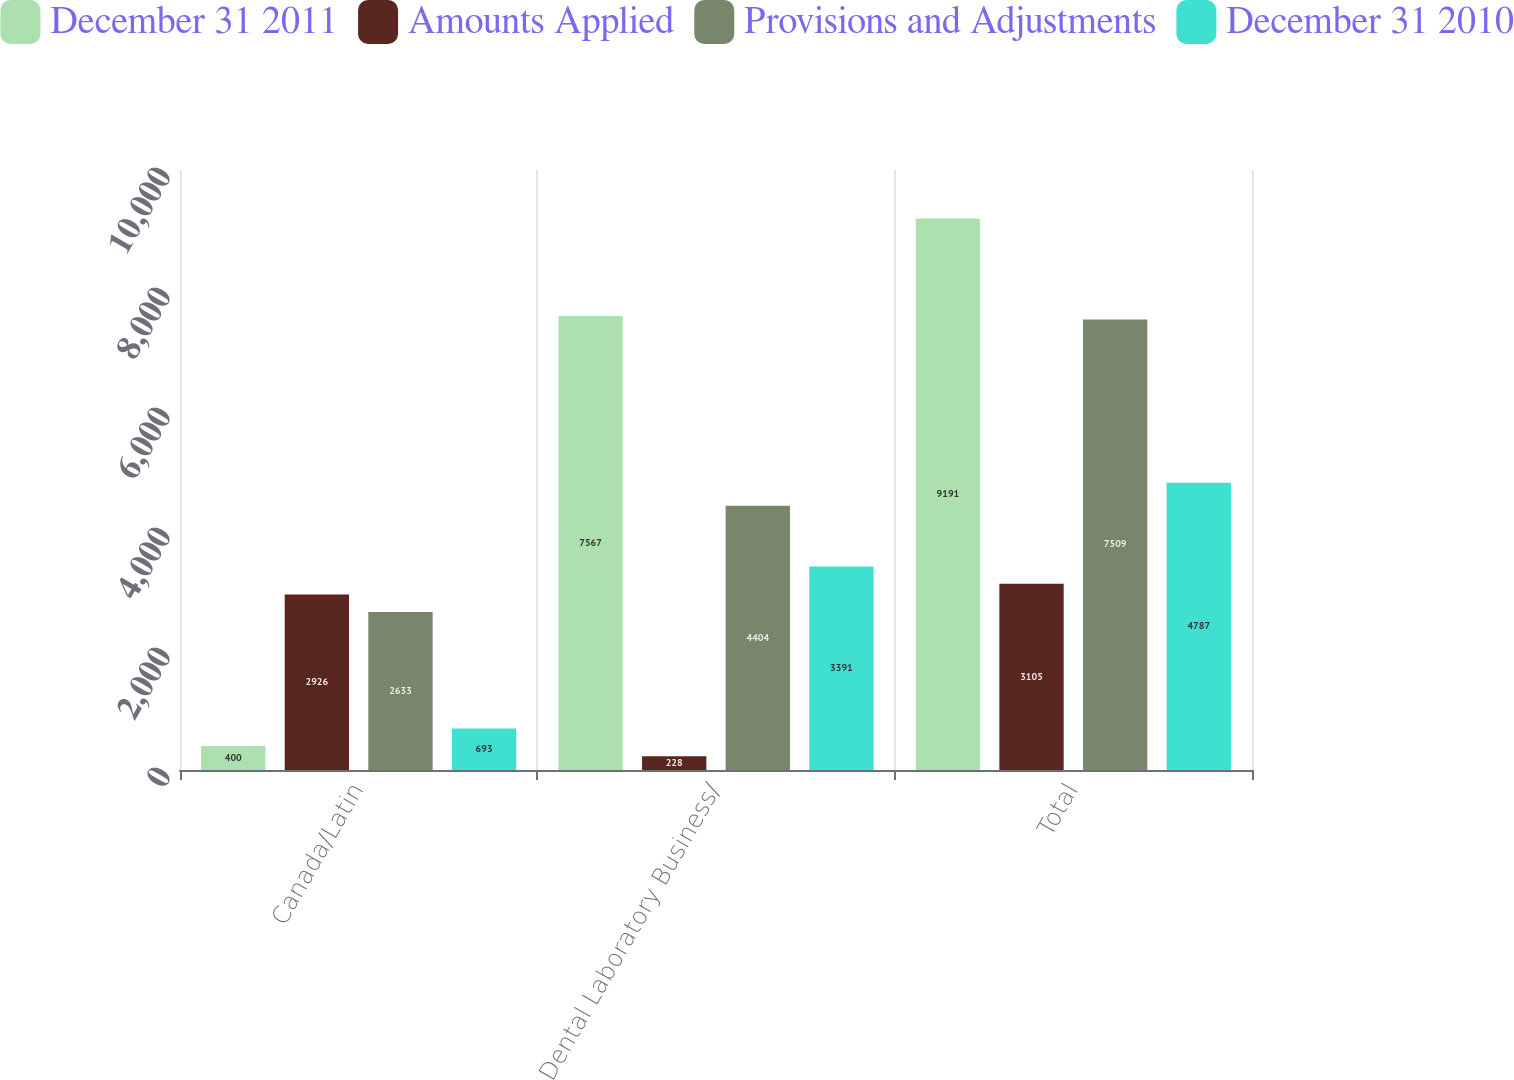Convert chart. <chart><loc_0><loc_0><loc_500><loc_500><stacked_bar_chart><ecel><fcel>Canada/Latin<fcel>Dental Laboratory Business/<fcel>Total<nl><fcel>December 31 2011<fcel>400<fcel>7567<fcel>9191<nl><fcel>Amounts Applied<fcel>2926<fcel>228<fcel>3105<nl><fcel>Provisions and Adjustments<fcel>2633<fcel>4404<fcel>7509<nl><fcel>December 31 2010<fcel>693<fcel>3391<fcel>4787<nl></chart> 